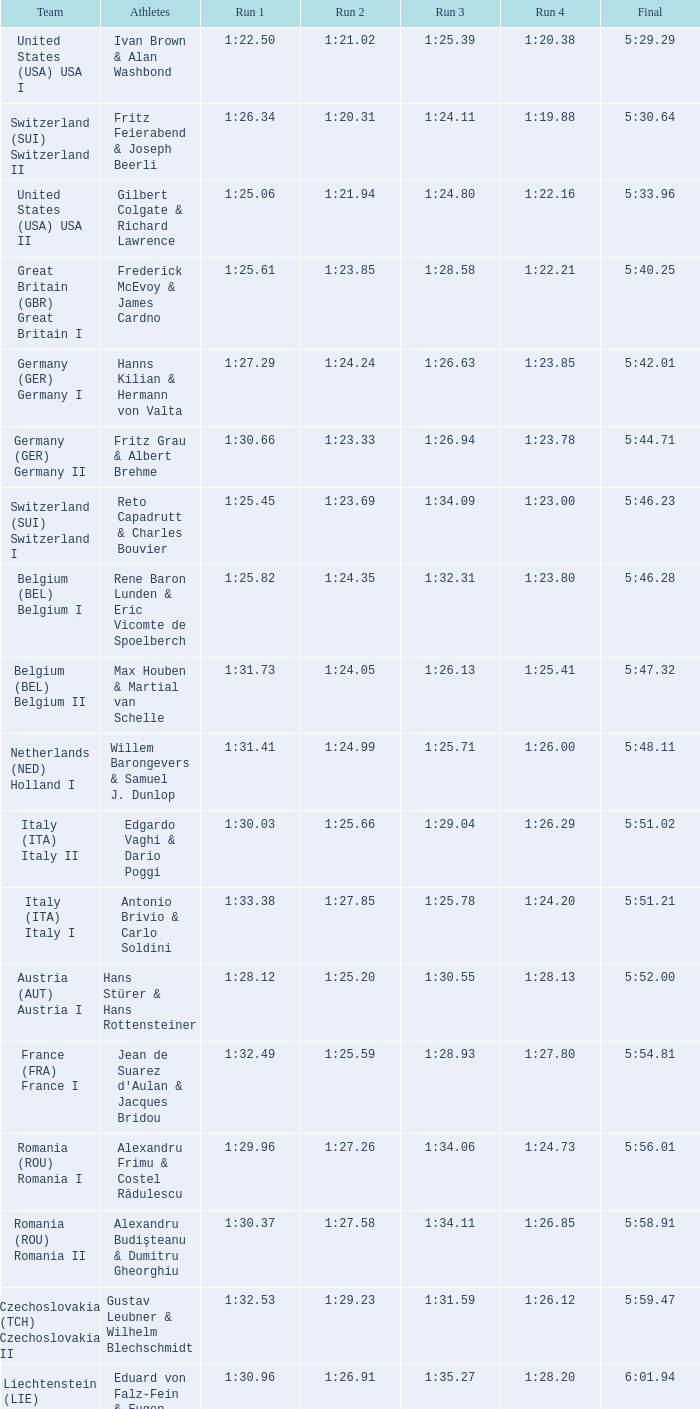Can you give me this table as a dict? {'header': ['Team', 'Athletes', 'Run 1', 'Run 2', 'Run 3', 'Run 4', 'Final'], 'rows': [['United States (USA) USA I', 'Ivan Brown & Alan Washbond', '1:22.50', '1:21.02', '1:25.39', '1:20.38', '5:29.29'], ['Switzerland (SUI) Switzerland II', 'Fritz Feierabend & Joseph Beerli', '1:26.34', '1:20.31', '1:24.11', '1:19.88', '5:30.64'], ['United States (USA) USA II', 'Gilbert Colgate & Richard Lawrence', '1:25.06', '1:21.94', '1:24.80', '1:22.16', '5:33.96'], ['Great Britain (GBR) Great Britain I', 'Frederick McEvoy & James Cardno', '1:25.61', '1:23.85', '1:28.58', '1:22.21', '5:40.25'], ['Germany (GER) Germany I', 'Hanns Kilian & Hermann von Valta', '1:27.29', '1:24.24', '1:26.63', '1:23.85', '5:42.01'], ['Germany (GER) Germany II', 'Fritz Grau & Albert Brehme', '1:30.66', '1:23.33', '1:26.94', '1:23.78', '5:44.71'], ['Switzerland (SUI) Switzerland I', 'Reto Capadrutt & Charles Bouvier', '1:25.45', '1:23.69', '1:34.09', '1:23.00', '5:46.23'], ['Belgium (BEL) Belgium I', 'Rene Baron Lunden & Eric Vicomte de Spoelberch', '1:25.82', '1:24.35', '1:32.31', '1:23.80', '5:46.28'], ['Belgium (BEL) Belgium II', 'Max Houben & Martial van Schelle', '1:31.73', '1:24.05', '1:26.13', '1:25.41', '5:47.32'], ['Netherlands (NED) Holland I', 'Willem Barongevers & Samuel J. Dunlop', '1:31.41', '1:24.99', '1:25.71', '1:26.00', '5:48.11'], ['Italy (ITA) Italy II', 'Edgardo Vaghi & Dario Poggi', '1:30.03', '1:25.66', '1:29.04', '1:26.29', '5:51.02'], ['Italy (ITA) Italy I', 'Antonio Brivio & Carlo Soldini', '1:33.38', '1:27.85', '1:25.78', '1:24.20', '5:51.21'], ['Austria (AUT) Austria I', 'Hans Stürer & Hans Rottensteiner', '1:28.12', '1:25.20', '1:30.55', '1:28.13', '5:52.00'], ['France (FRA) France I', "Jean de Suarez d'Aulan & Jacques Bridou", '1:32.49', '1:25.59', '1:28.93', '1:27.80', '5:54.81'], ['Romania (ROU) Romania I', 'Alexandru Frimu & Costel Rădulescu', '1:29.96', '1:27.26', '1:34.06', '1:24.73', '5:56.01'], ['Romania (ROU) Romania II', 'Alexandru Budişteanu & Dumitru Gheorghiu', '1:30.37', '1:27.58', '1:34.11', '1:26.85', '5:58.91'], ['Czechoslovakia (TCH) Czechoslovakia II', 'Gustav Leubner & Wilhelm Blechschmidt', '1:32.53', '1:29.23', '1:31.59', '1:26.12', '5:59.47'], ['Liechtenstein (LIE) Liechtenstein I', 'Eduard von Falz-Fein & Eugen Büchel', '1:30.96', '1:26.91', '1:35.27', '1:28.20', '6:01.94'], ['Austria (AUT) Austria II', 'Hans Volckmar & Anton Kaltenberger', '1:33.71', '1:26.28', '1:30.50', '1:31.81', '6:02.30'], ['Czechoslovakia (TCH) Czechoslovakia II', 'Josef Lanzendörfer & Karel Růžička', '1:31.40', '1:28.90', '1:36.57', '1:32.83', '6:09.70'], ['France (FRA) France II', 'Louis Bozon & Émile Kleber', '1:41.99', '1:31.92', '1:35.09', '1:31.07', '6:20.07'], ['Luxembourg (LUX) Luxembourg I', 'Raoul Weckbecker & Géza Wertheim', '1:45.41', '1:33.95', '1:35.96', '1:37.47', '6:32.79'], ['Luxembourg (LUX) Luxembourg II', 'Henri Koch & Gustav Wagner', '1:42.02', '1:31.91', '1:29.76', 'NM', 'DNF']]} Which Run 4 has Athletes of alexandru frimu & costel rădulescu? 1:24.73. 